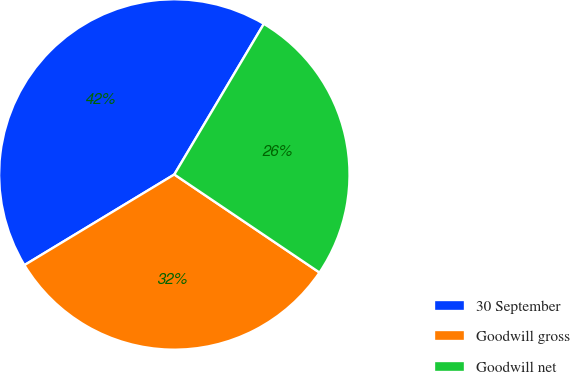Convert chart. <chart><loc_0><loc_0><loc_500><loc_500><pie_chart><fcel>30 September<fcel>Goodwill gross<fcel>Goodwill net<nl><fcel>42.19%<fcel>31.89%<fcel>25.92%<nl></chart> 